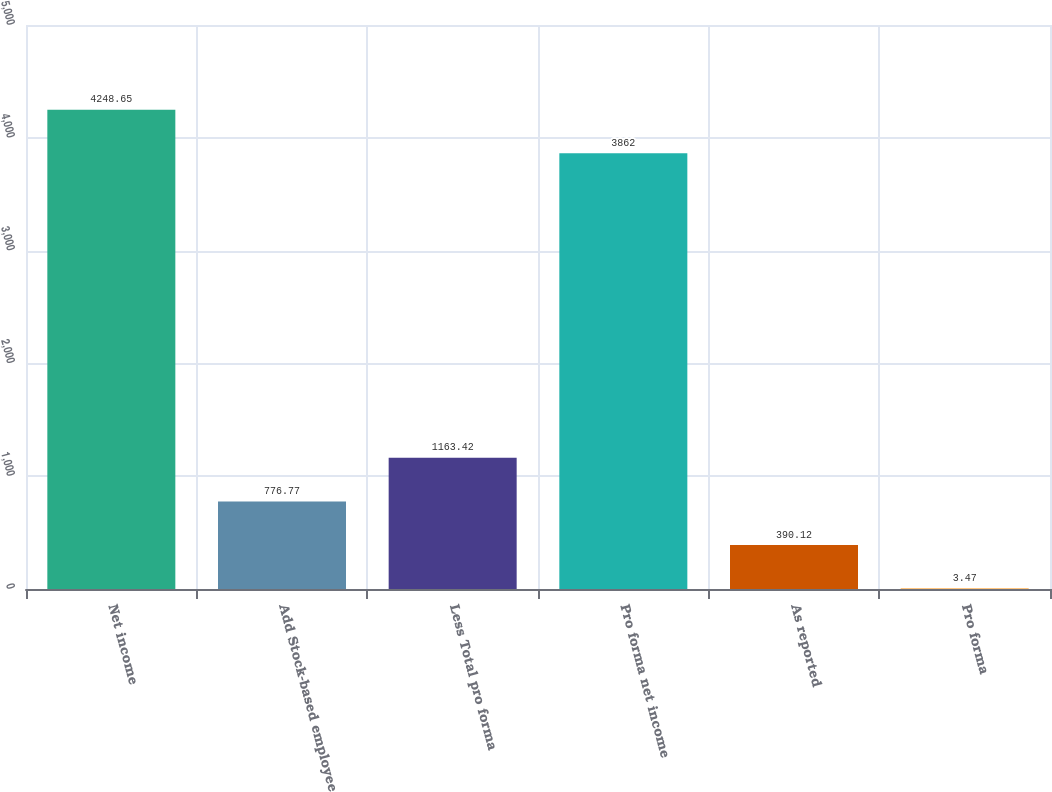Convert chart to OTSL. <chart><loc_0><loc_0><loc_500><loc_500><bar_chart><fcel>Net income<fcel>Add Stock-based employee<fcel>Less Total pro forma<fcel>Pro forma net income<fcel>As reported<fcel>Pro forma<nl><fcel>4248.65<fcel>776.77<fcel>1163.42<fcel>3862<fcel>390.12<fcel>3.47<nl></chart> 